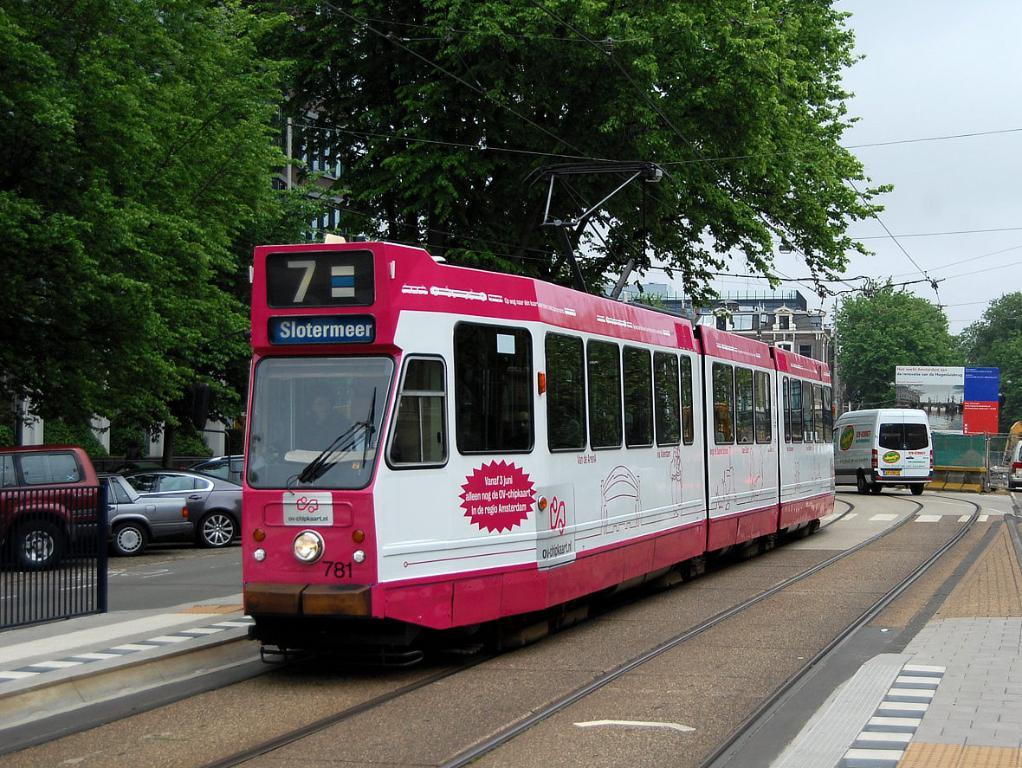<image>
Share a concise interpretation of the image provided. A pink and white train that says 7 and Slotermeer on the front/ 